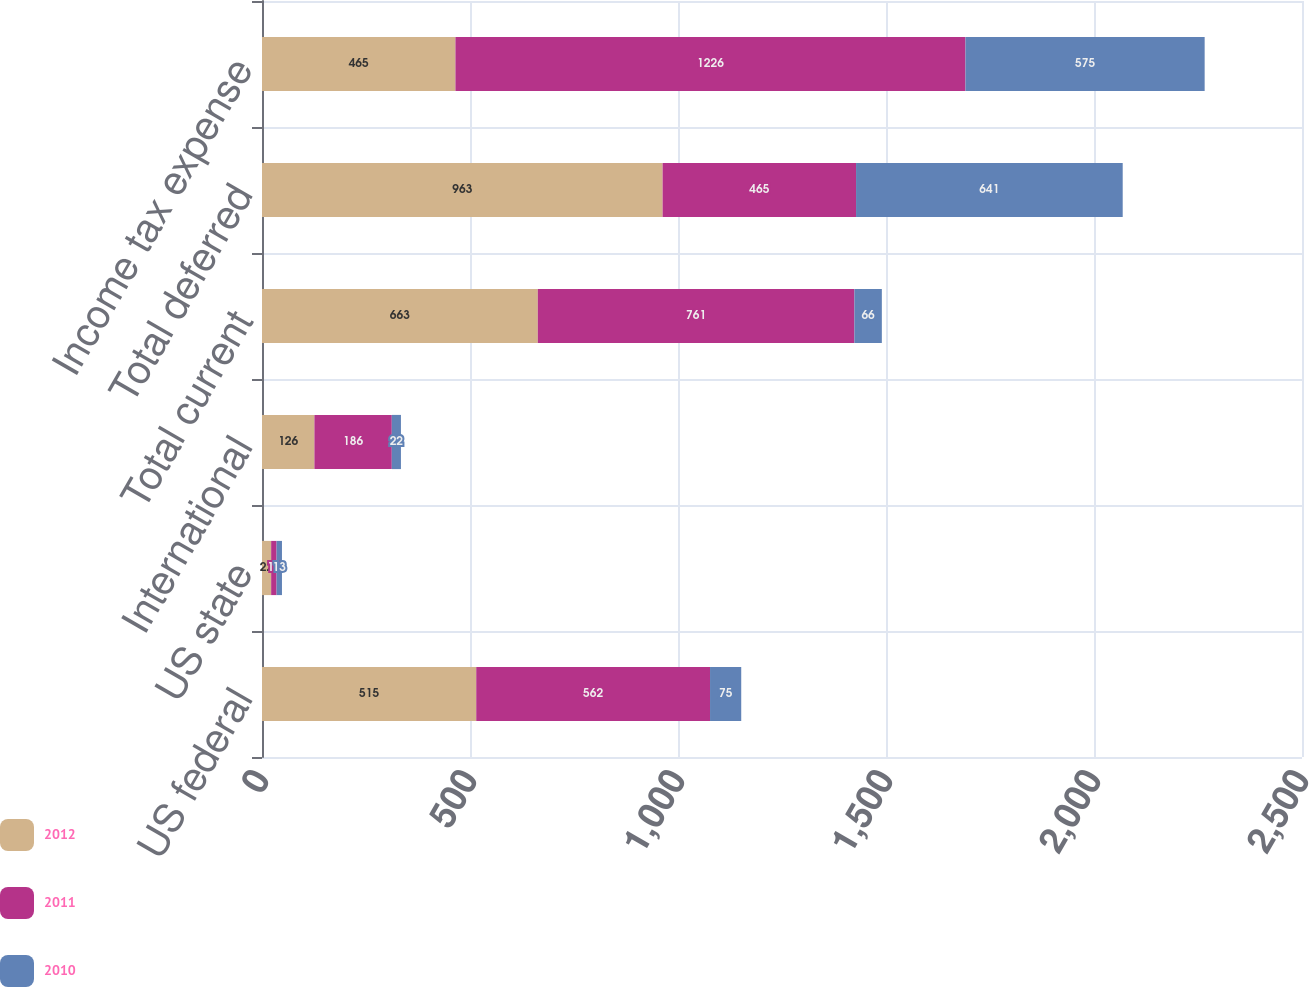<chart> <loc_0><loc_0><loc_500><loc_500><stacked_bar_chart><ecel><fcel>US federal<fcel>US state<fcel>International<fcel>Total current<fcel>Total deferred<fcel>Income tax expense<nl><fcel>2012<fcel>515<fcel>22<fcel>126<fcel>663<fcel>963<fcel>465<nl><fcel>2011<fcel>562<fcel>13<fcel>186<fcel>761<fcel>465<fcel>1226<nl><fcel>2010<fcel>75<fcel>13<fcel>22<fcel>66<fcel>641<fcel>575<nl></chart> 